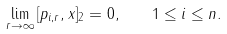<formula> <loc_0><loc_0><loc_500><loc_500>\lim _ { r \to \infty } \| [ p _ { i , r } , x ] \| _ { 2 } = 0 , \quad 1 \leq i \leq n .</formula> 